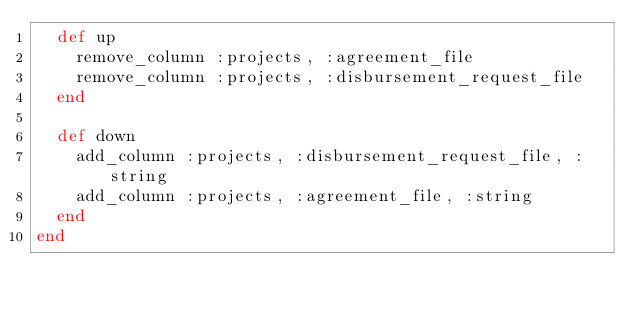<code> <loc_0><loc_0><loc_500><loc_500><_Ruby_>  def up
    remove_column :projects, :agreement_file
    remove_column :projects, :disbursement_request_file
  end

  def down
    add_column :projects, :disbursement_request_file, :string
    add_column :projects, :agreement_file, :string
  end
end
</code> 